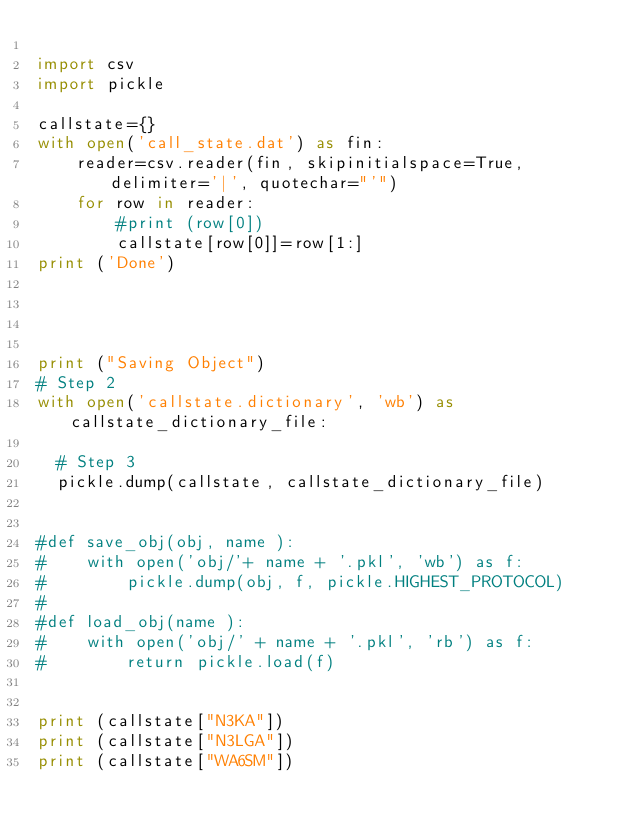<code> <loc_0><loc_0><loc_500><loc_500><_Python_>
import csv
import pickle

callstate={}
with open('call_state.dat') as fin:
    reader=csv.reader(fin, skipinitialspace=True, delimiter='|', quotechar="'")
    for row in reader:
        #print (row[0])
        callstate[row[0]]=row[1:]
print ('Done')




print ("Saving Object")
# Step 2
with open('callstate.dictionary', 'wb') as callstate_dictionary_file:
 
  # Step 3
  pickle.dump(callstate, callstate_dictionary_file)


#def save_obj(obj, name ):
#    with open('obj/'+ name + '.pkl', 'wb') as f:
#        pickle.dump(obj, f, pickle.HIGHEST_PROTOCOL)
#
#def load_obj(name ):
#    with open('obj/' + name + '.pkl', 'rb') as f:
#        return pickle.load(f)


print (callstate["N3KA"])
print (callstate["N3LGA"])
print (callstate["WA6SM"])
</code> 